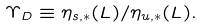Convert formula to latex. <formula><loc_0><loc_0><loc_500><loc_500>\Upsilon _ { D } \equiv \eta _ { s , * } ( L ) / \eta _ { u , * } ( L ) .</formula> 